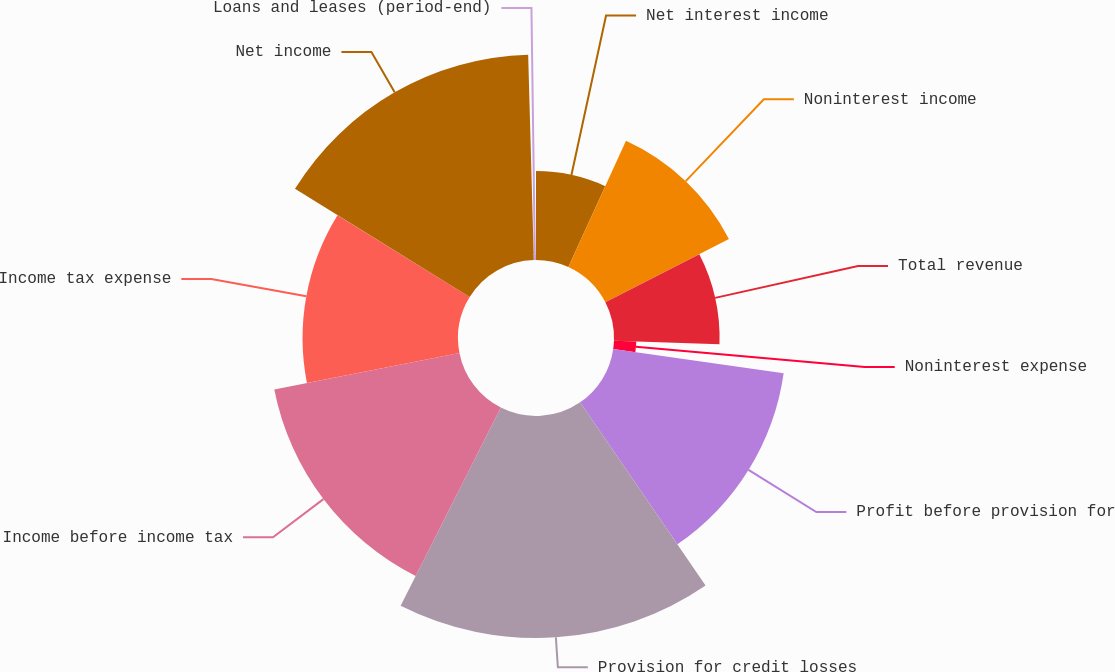<chart> <loc_0><loc_0><loc_500><loc_500><pie_chart><fcel>Net interest income<fcel>Noninterest income<fcel>Total revenue<fcel>Noninterest expense<fcel>Profit before provision for<fcel>Provision for credit losses<fcel>Income before income tax<fcel>Income tax expense<fcel>Net income<fcel>Loans and leases (period-end)<nl><fcel>6.81%<fcel>10.64%<fcel>8.09%<fcel>1.71%<fcel>13.19%<fcel>17.01%<fcel>14.46%<fcel>11.91%<fcel>15.74%<fcel>0.44%<nl></chart> 